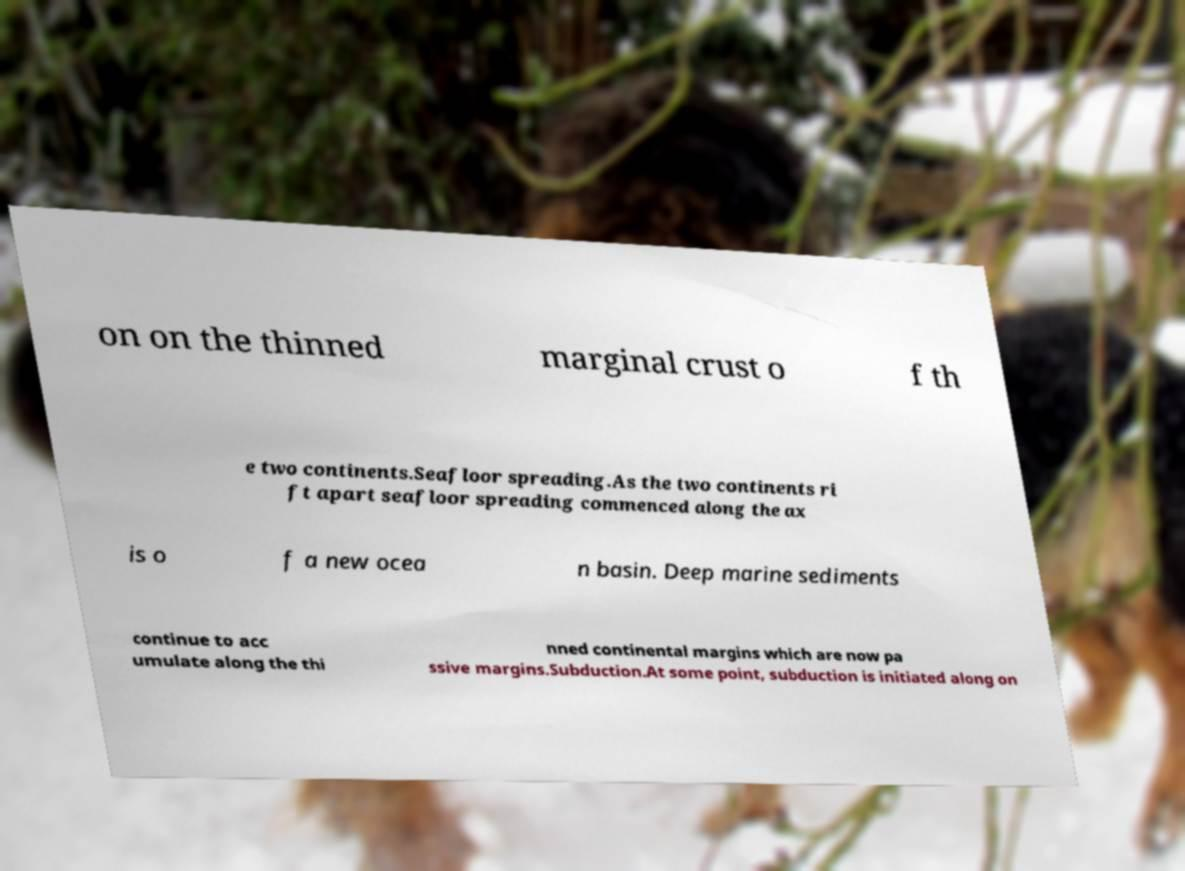For documentation purposes, I need the text within this image transcribed. Could you provide that? on on the thinned marginal crust o f th e two continents.Seafloor spreading.As the two continents ri ft apart seafloor spreading commenced along the ax is o f a new ocea n basin. Deep marine sediments continue to acc umulate along the thi nned continental margins which are now pa ssive margins.Subduction.At some point, subduction is initiated along on 